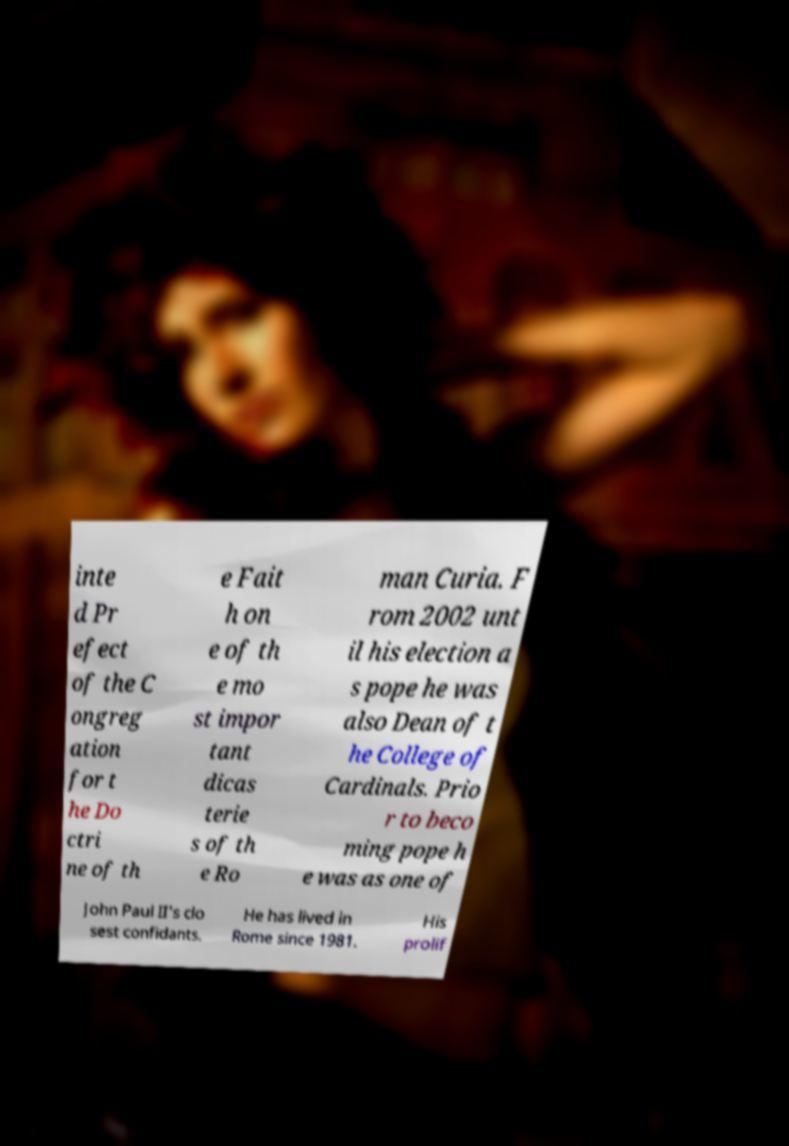What messages or text are displayed in this image? I need them in a readable, typed format. inte d Pr efect of the C ongreg ation for t he Do ctri ne of th e Fait h on e of th e mo st impor tant dicas terie s of th e Ro man Curia. F rom 2002 unt il his election a s pope he was also Dean of t he College of Cardinals. Prio r to beco ming pope h e was as one of John Paul II's clo sest confidants. He has lived in Rome since 1981. His prolif 